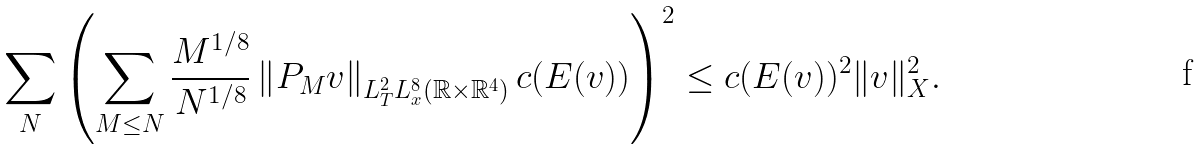<formula> <loc_0><loc_0><loc_500><loc_500>\sum _ { N } \left ( \sum _ { M \leq N } \frac { M ^ { 1 / 8 } } { N ^ { 1 / 8 } } \left \| P _ { M } v \right \| _ { L _ { T } ^ { 2 } L _ { x } ^ { 8 } ( \mathbb { R } \times \mathbb { R } ^ { 4 } ) } c ( E ( v ) ) \right ) ^ { 2 } \leq c ( E ( v ) ) ^ { 2 } \| v \| _ { X } ^ { 2 } .</formula> 